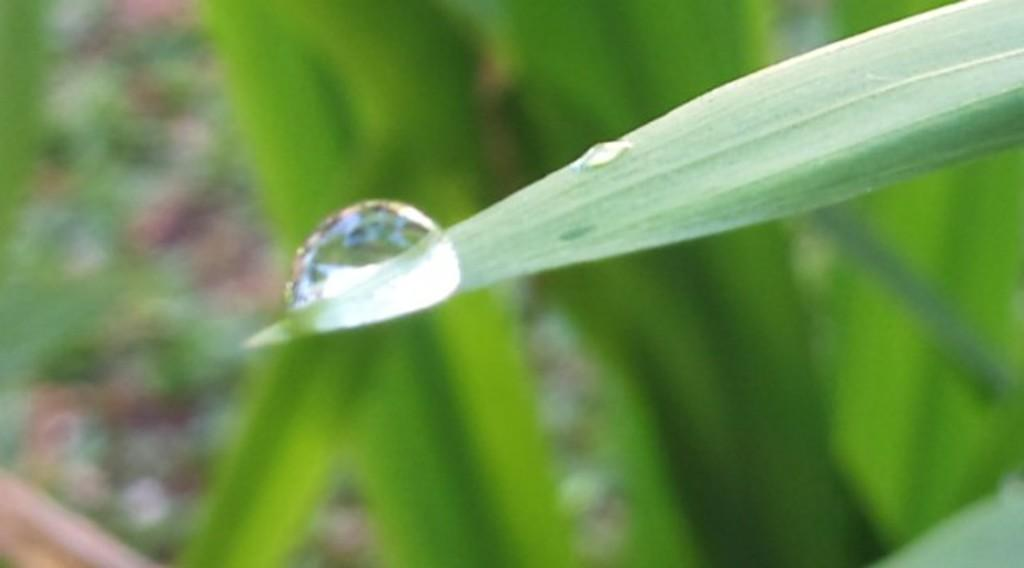What is the main subject of the image? The main subject of the image is a water droplet. Where is the water droplet located in the image? The water droplet is on a leaf in the center of the image. What can be seen in the background of the image? There is greenery in the background of the image. How many tails can be seen in the image? There are no tails present in the image. Is the image taken during the night? The image does not provide information about the time of day, but there is no indication of it being nighttime. 